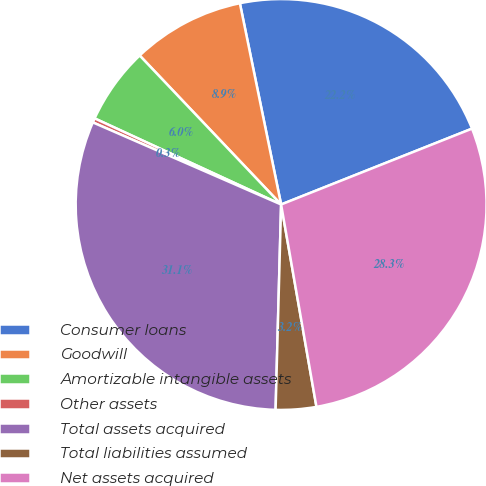Convert chart. <chart><loc_0><loc_0><loc_500><loc_500><pie_chart><fcel>Consumer loans<fcel>Goodwill<fcel>Amortizable intangible assets<fcel>Other assets<fcel>Total assets acquired<fcel>Total liabilities assumed<fcel>Net assets acquired<nl><fcel>22.2%<fcel>8.87%<fcel>6.03%<fcel>0.34%<fcel>31.12%<fcel>3.18%<fcel>28.27%<nl></chart> 